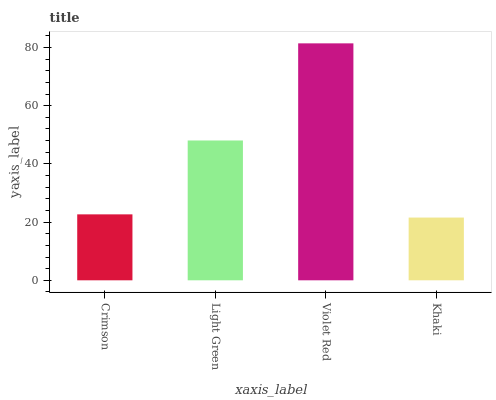Is Khaki the minimum?
Answer yes or no. Yes. Is Violet Red the maximum?
Answer yes or no. Yes. Is Light Green the minimum?
Answer yes or no. No. Is Light Green the maximum?
Answer yes or no. No. Is Light Green greater than Crimson?
Answer yes or no. Yes. Is Crimson less than Light Green?
Answer yes or no. Yes. Is Crimson greater than Light Green?
Answer yes or no. No. Is Light Green less than Crimson?
Answer yes or no. No. Is Light Green the high median?
Answer yes or no. Yes. Is Crimson the low median?
Answer yes or no. Yes. Is Khaki the high median?
Answer yes or no. No. Is Khaki the low median?
Answer yes or no. No. 